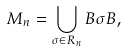Convert formula to latex. <formula><loc_0><loc_0><loc_500><loc_500>M _ { n } = \bigcup _ { \sigma \in R _ { n } } B \sigma B ,</formula> 